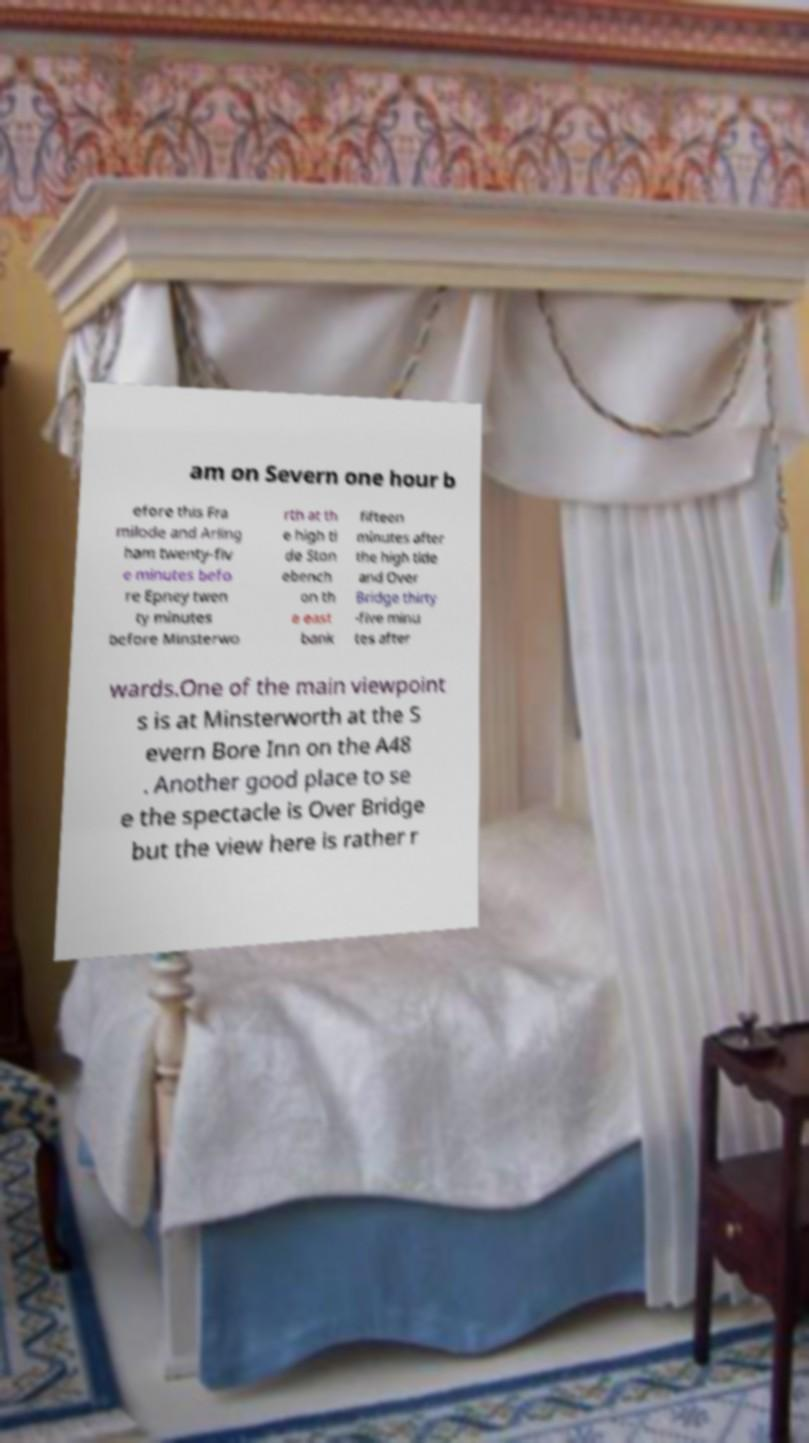Could you assist in decoding the text presented in this image and type it out clearly? am on Severn one hour b efore this Fra milode and Arling ham twenty-fiv e minutes befo re Epney twen ty minutes before Minsterwo rth at th e high ti de Ston ebench on th e east bank fifteen minutes after the high tide and Over Bridge thirty -five minu tes after wards.One of the main viewpoint s is at Minsterworth at the S evern Bore Inn on the A48 . Another good place to se e the spectacle is Over Bridge but the view here is rather r 